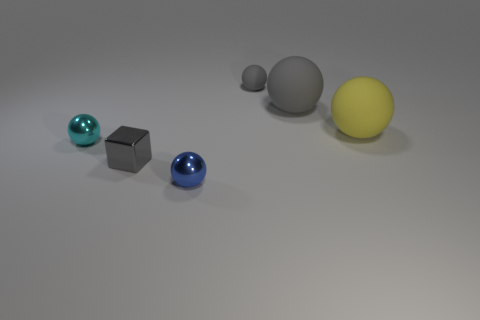Subtract all cyan shiny balls. How many balls are left? 4 Subtract all cubes. How many objects are left? 5 Subtract all yellow balls. How many balls are left? 4 Add 2 cyan balls. How many objects exist? 8 Subtract all yellow objects. Subtract all tiny blue metallic balls. How many objects are left? 4 Add 2 large matte objects. How many large matte objects are left? 4 Add 3 small gray metallic cubes. How many small gray metallic cubes exist? 4 Subtract 0 purple cylinders. How many objects are left? 6 Subtract 1 cubes. How many cubes are left? 0 Subtract all brown balls. Subtract all red cubes. How many balls are left? 5 